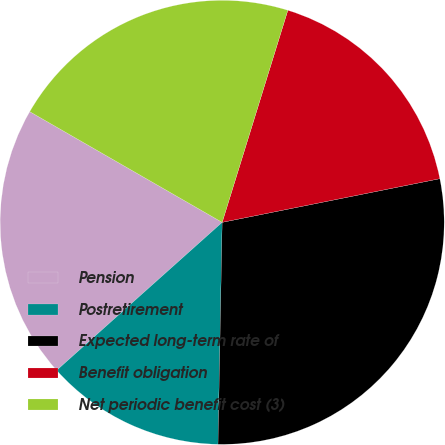<chart> <loc_0><loc_0><loc_500><loc_500><pie_chart><fcel>Pension<fcel>Postretirement<fcel>Expected long-term rate of<fcel>Benefit obligation<fcel>Net periodic benefit cost (3)<nl><fcel>19.92%<fcel>13.09%<fcel>28.45%<fcel>17.07%<fcel>21.47%<nl></chart> 